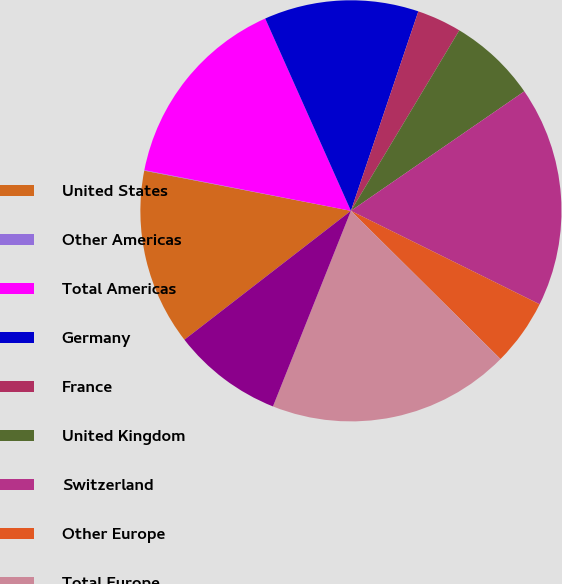<chart> <loc_0><loc_0><loc_500><loc_500><pie_chart><fcel>United States<fcel>Other Americas<fcel>Total Americas<fcel>Germany<fcel>France<fcel>United Kingdom<fcel>Switzerland<fcel>Other Europe<fcel>Total Europe<fcel>China<nl><fcel>13.54%<fcel>0.04%<fcel>15.23%<fcel>11.86%<fcel>3.42%<fcel>6.79%<fcel>16.92%<fcel>5.11%<fcel>18.61%<fcel>8.48%<nl></chart> 